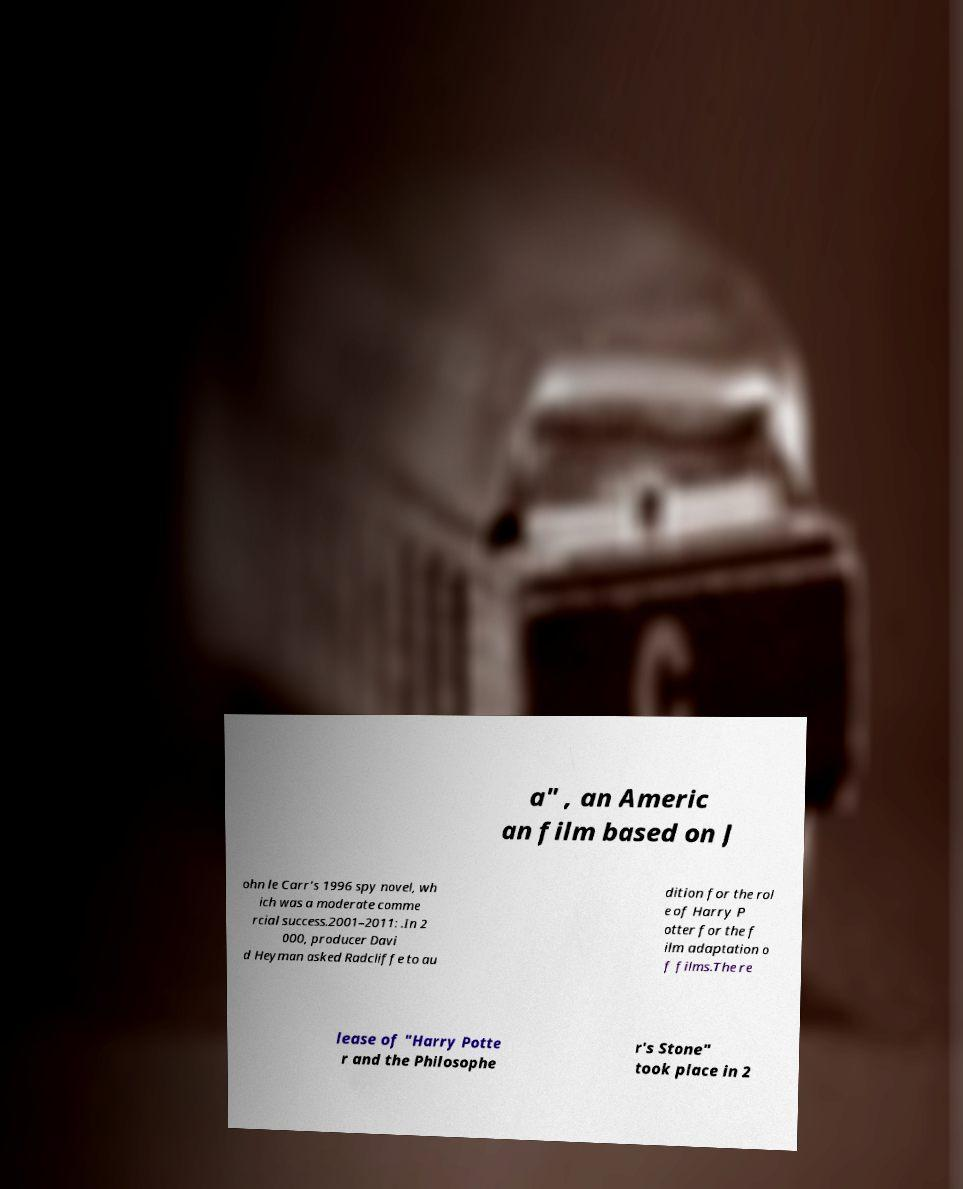I need the written content from this picture converted into text. Can you do that? a" , an Americ an film based on J ohn le Carr's 1996 spy novel, wh ich was a moderate comme rcial success.2001–2011: .In 2 000, producer Davi d Heyman asked Radcliffe to au dition for the rol e of Harry P otter for the f ilm adaptation o f films.The re lease of "Harry Potte r and the Philosophe r's Stone" took place in 2 